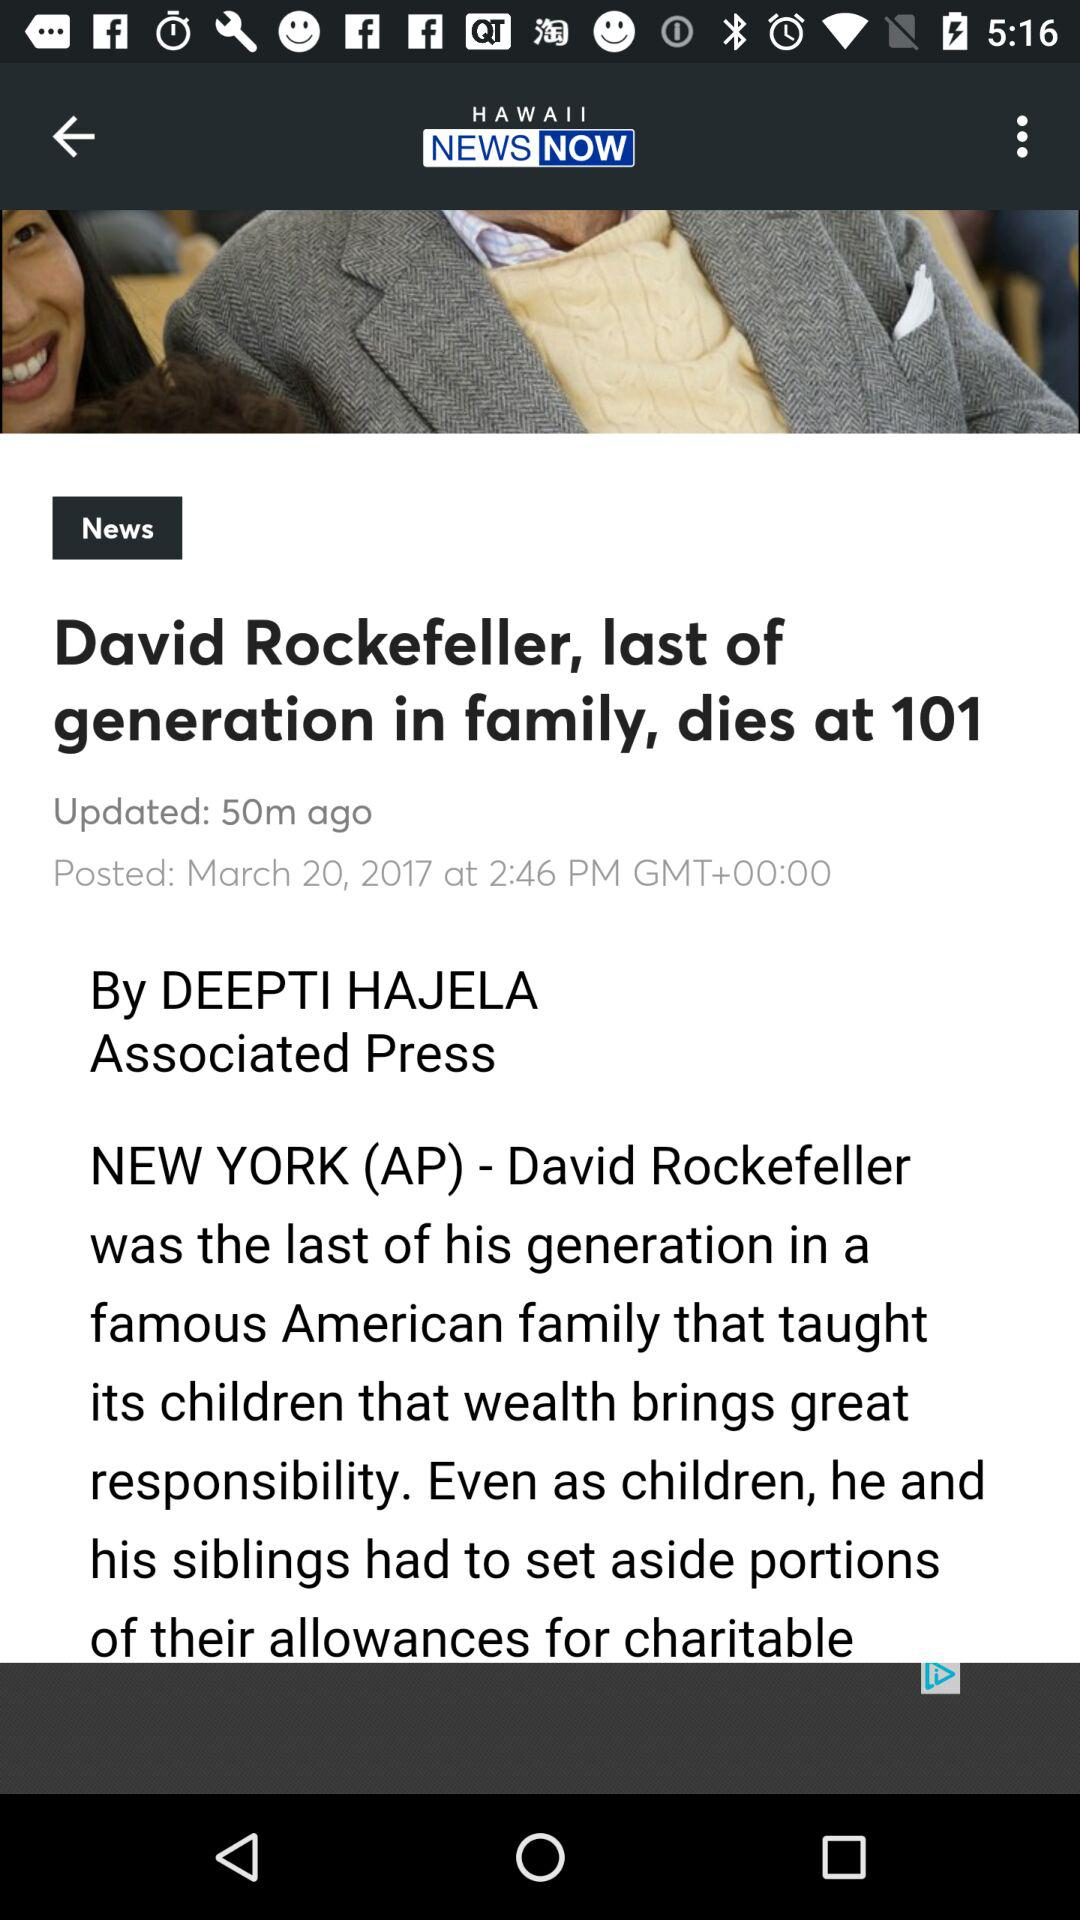When was it updated? It was last updated 50 minutes ago. 